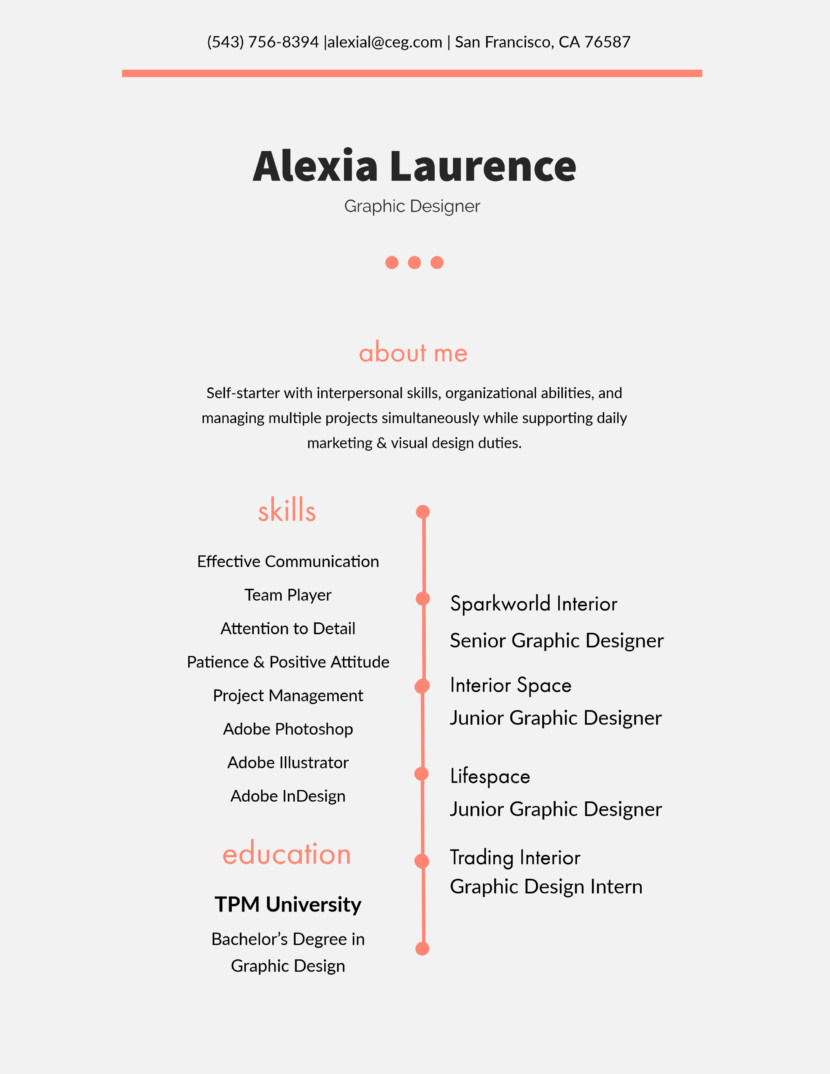Can you infer how Alexia's interpersonal skills have played a role in her career progression? Alexia's career progression likely benefited greatly from her interpersonal skills. These abilities are critical in collaborative environments like graphic design, where coordinating with other team members and clients is essential. Effective communication, being a team player, and a positive attitude likely helped her navigate the challenges of taking on more responsibility in higher roles, such as her current position at Sparkworld Interior. 